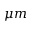Convert formula to latex. <formula><loc_0><loc_0><loc_500><loc_500>\mu m</formula> 